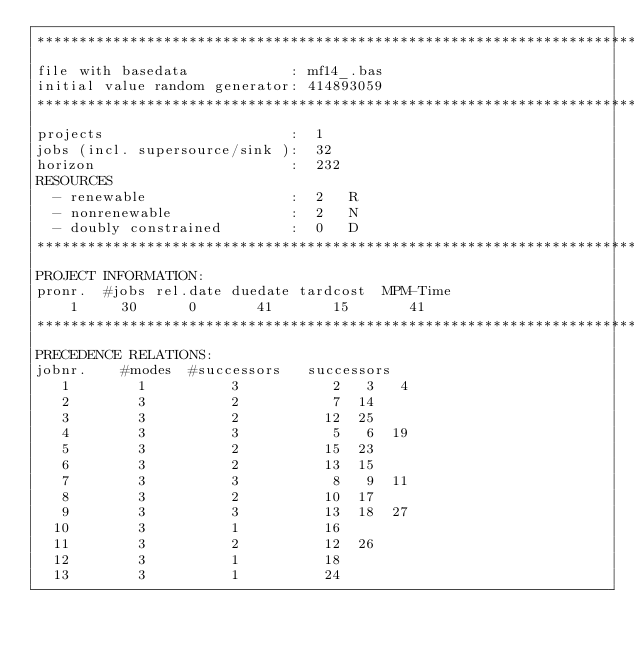<code> <loc_0><loc_0><loc_500><loc_500><_ObjectiveC_>************************************************************************
file with basedata            : mf14_.bas
initial value random generator: 414893059
************************************************************************
projects                      :  1
jobs (incl. supersource/sink ):  32
horizon                       :  232
RESOURCES
  - renewable                 :  2   R
  - nonrenewable              :  2   N
  - doubly constrained        :  0   D
************************************************************************
PROJECT INFORMATION:
pronr.  #jobs rel.date duedate tardcost  MPM-Time
    1     30      0       41       15       41
************************************************************************
PRECEDENCE RELATIONS:
jobnr.    #modes  #successors   successors
   1        1          3           2   3   4
   2        3          2           7  14
   3        3          2          12  25
   4        3          3           5   6  19
   5        3          2          15  23
   6        3          2          13  15
   7        3          3           8   9  11
   8        3          2          10  17
   9        3          3          13  18  27
  10        3          1          16
  11        3          2          12  26
  12        3          1          18
  13        3          1          24</code> 